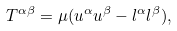Convert formula to latex. <formula><loc_0><loc_0><loc_500><loc_500>T ^ { \alpha \beta } = \mu ( u ^ { \alpha } u ^ { \beta } - l ^ { \alpha } l ^ { \beta } ) ,</formula> 